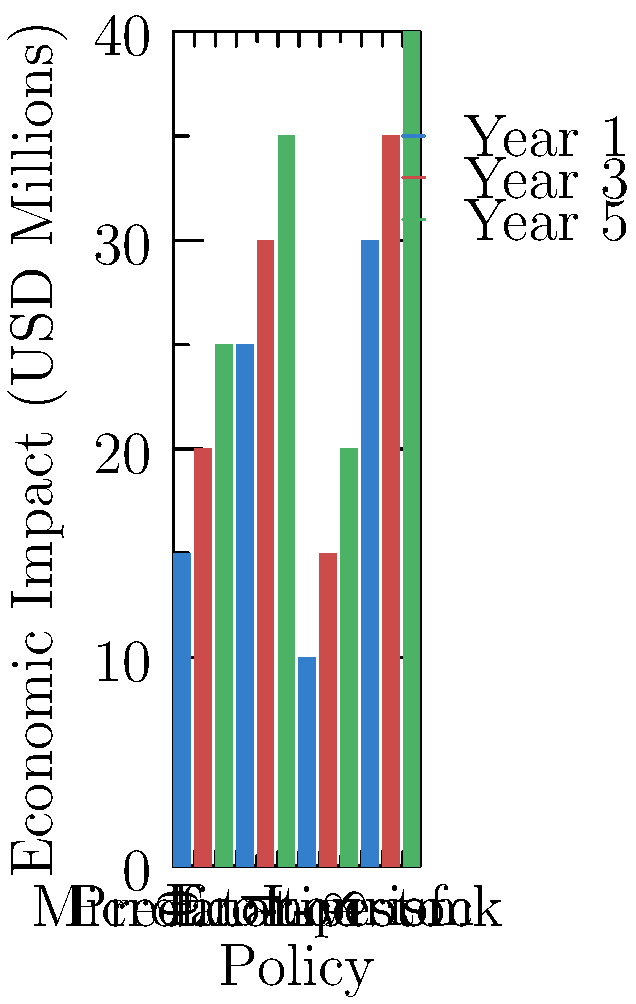Based on the bar graph showing the economic impacts of various herder support policies over a 5-year period, which policy demonstrates the highest percentage increase from Year 1 to Year 5, and what is the approximate percentage increase? To solve this problem, we need to follow these steps:

1. Identify the initial (Year 1) and final (Year 5) values for each policy:

   Microfinance: Year 1 = $15 million, Year 5 = $25 million
   Predator-proof: Year 1 = $25 million, Year 5 = $35 million
   Eco-tourism: Year 1 = $10 million, Year 5 = $20 million
   Livestock: Year 1 = $30 million, Year 5 = $40 million

2. Calculate the percentage increase for each policy using the formula:
   Percentage increase = (Final value - Initial value) / Initial value * 100

   Microfinance: (25 - 15) / 15 * 100 = 66.67%
   Predator-proof: (35 - 25) / 25 * 100 = 40%
   Eco-tourism: (20 - 10) / 10 * 100 = 100%
   Livestock: (40 - 30) / 30 * 100 = 33.33%

3. Compare the percentage increases to identify the highest:
   Eco-tourism has the highest percentage increase at 100%.

Therefore, the policy with the highest percentage increase from Year 1 to Year 5 is Eco-tourism, with an approximate increase of 100%.
Answer: Eco-tourism, 100% 